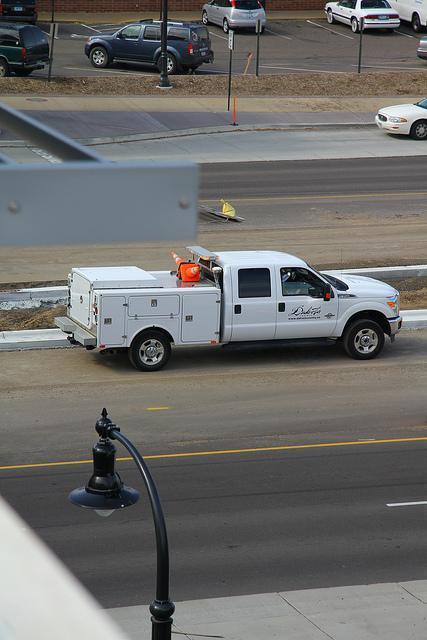How many cars are in the photo?
Give a very brief answer. 2. How many people have on glasses?
Give a very brief answer. 0. 